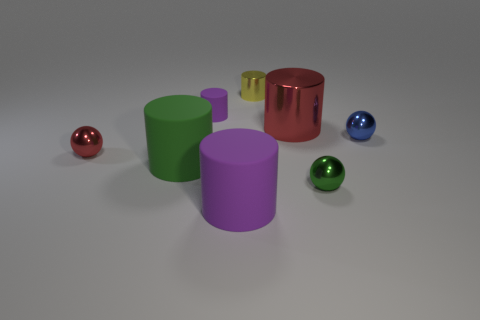Subtract 2 cylinders. How many cylinders are left? 3 Subtract all red cylinders. How many cylinders are left? 4 Subtract all big green cylinders. How many cylinders are left? 4 Subtract all yellow spheres. Subtract all green cylinders. How many spheres are left? 3 Add 2 large green matte things. How many objects exist? 10 Subtract all spheres. How many objects are left? 5 Subtract all brown shiny cylinders. Subtract all red metal objects. How many objects are left? 6 Add 7 big green cylinders. How many big green cylinders are left? 8 Add 4 purple rubber things. How many purple rubber things exist? 6 Subtract 0 cyan cylinders. How many objects are left? 8 